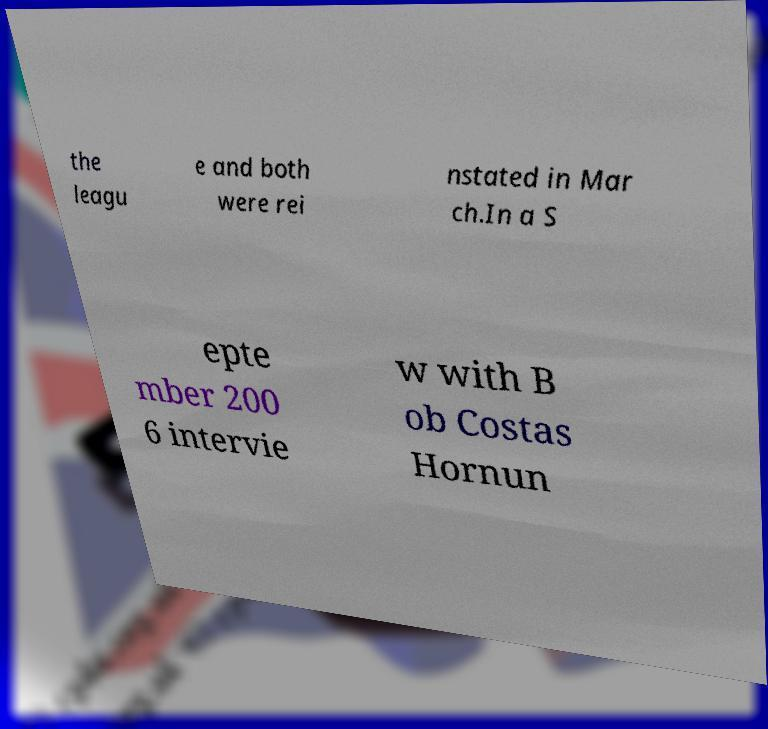There's text embedded in this image that I need extracted. Can you transcribe it verbatim? the leagu e and both were rei nstated in Mar ch.In a S epte mber 200 6 intervie w with B ob Costas Hornun 